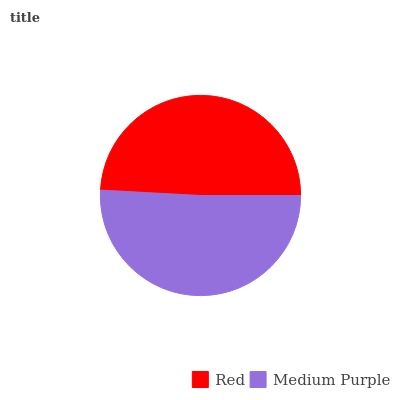Is Red the minimum?
Answer yes or no. Yes. Is Medium Purple the maximum?
Answer yes or no. Yes. Is Medium Purple the minimum?
Answer yes or no. No. Is Medium Purple greater than Red?
Answer yes or no. Yes. Is Red less than Medium Purple?
Answer yes or no. Yes. Is Red greater than Medium Purple?
Answer yes or no. No. Is Medium Purple less than Red?
Answer yes or no. No. Is Medium Purple the high median?
Answer yes or no. Yes. Is Red the low median?
Answer yes or no. Yes. Is Red the high median?
Answer yes or no. No. Is Medium Purple the low median?
Answer yes or no. No. 